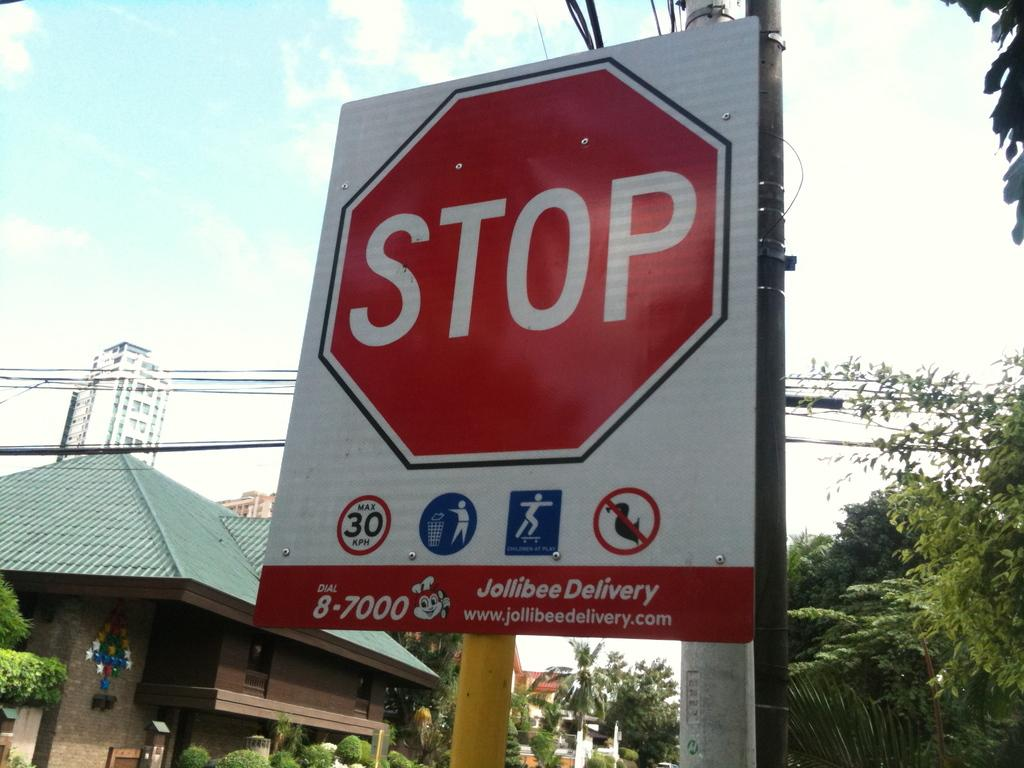Provide a one-sentence caption for the provided image. Stop Sign hosted by Jollibee Delivery, Max Speed is 30 KPH. 